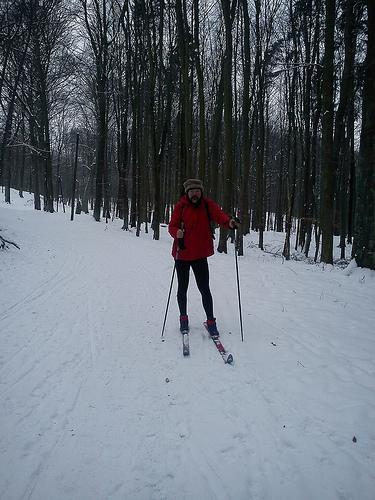How many skiers?
Give a very brief answer. 1. 